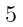<formula> <loc_0><loc_0><loc_500><loc_500>\begin{smallmatrix} \ \\ 5 \\ \ \end{smallmatrix}</formula> 